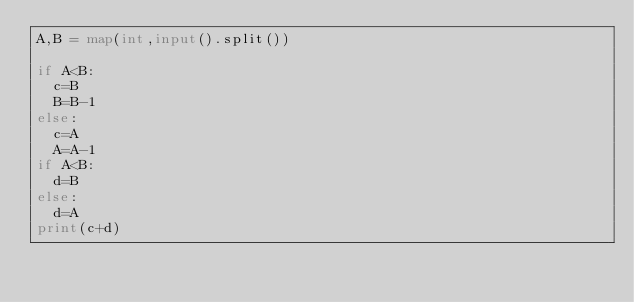<code> <loc_0><loc_0><loc_500><loc_500><_Python_>A,B = map(int,input().split())

if A<B:
  c=B
  B=B-1
else:
  c=A
  A=A-1
if A<B:
  d=B
else:
  d=A
print(c+d)
  
</code> 